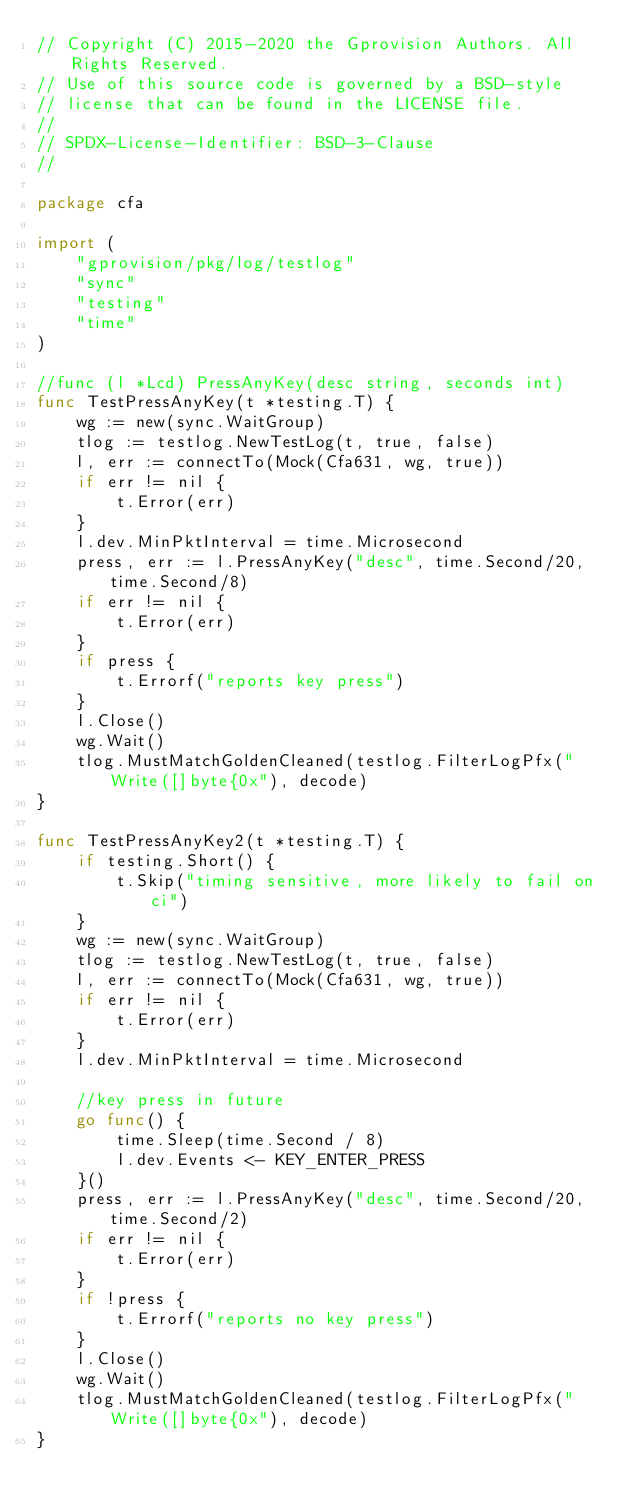Convert code to text. <code><loc_0><loc_0><loc_500><loc_500><_Go_>// Copyright (C) 2015-2020 the Gprovision Authors. All Rights Reserved.
// Use of this source code is governed by a BSD-style
// license that can be found in the LICENSE file.
//
// SPDX-License-Identifier: BSD-3-Clause
//

package cfa

import (
	"gprovision/pkg/log/testlog"
	"sync"
	"testing"
	"time"
)

//func (l *Lcd) PressAnyKey(desc string, seconds int)
func TestPressAnyKey(t *testing.T) {
	wg := new(sync.WaitGroup)
	tlog := testlog.NewTestLog(t, true, false)
	l, err := connectTo(Mock(Cfa631, wg, true))
	if err != nil {
		t.Error(err)
	}
	l.dev.MinPktInterval = time.Microsecond
	press, err := l.PressAnyKey("desc", time.Second/20, time.Second/8)
	if err != nil {
		t.Error(err)
	}
	if press {
		t.Errorf("reports key press")
	}
	l.Close()
	wg.Wait()
	tlog.MustMatchGoldenCleaned(testlog.FilterLogPfx("Write([]byte{0x"), decode)
}

func TestPressAnyKey2(t *testing.T) {
	if testing.Short() {
		t.Skip("timing sensitive, more likely to fail on ci")
	}
	wg := new(sync.WaitGroup)
	tlog := testlog.NewTestLog(t, true, false)
	l, err := connectTo(Mock(Cfa631, wg, true))
	if err != nil {
		t.Error(err)
	}
	l.dev.MinPktInterval = time.Microsecond

	//key press in future
	go func() {
		time.Sleep(time.Second / 8)
		l.dev.Events <- KEY_ENTER_PRESS
	}()
	press, err := l.PressAnyKey("desc", time.Second/20, time.Second/2)
	if err != nil {
		t.Error(err)
	}
	if !press {
		t.Errorf("reports no key press")
	}
	l.Close()
	wg.Wait()
	tlog.MustMatchGoldenCleaned(testlog.FilterLogPfx("Write([]byte{0x"), decode)
}
</code> 